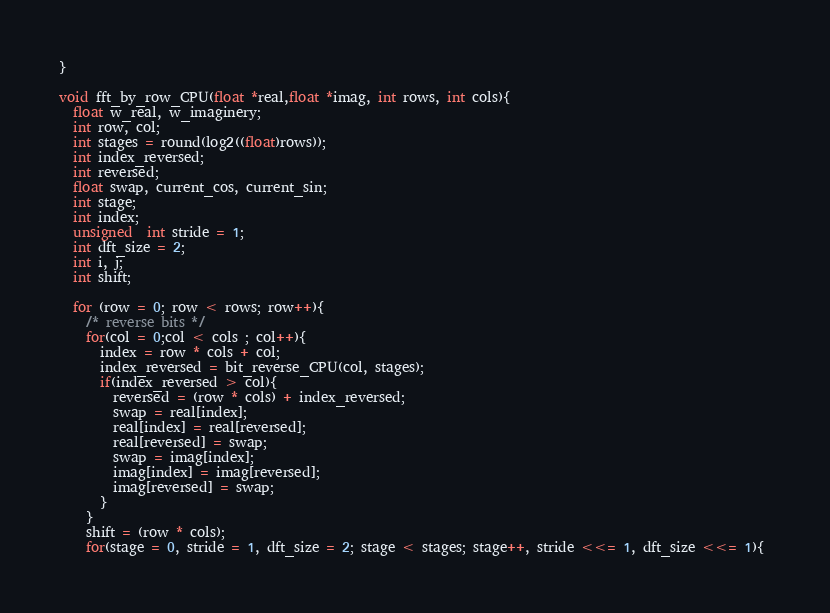<code> <loc_0><loc_0><loc_500><loc_500><_Cuda_>}

void fft_by_row_CPU(float *real,float *imag, int rows, int cols){
  float w_real, w_imaginery;
  int row, col;
  int stages = round(log2((float)rows));
  int index_reversed;
  int reversed;
  float swap, current_cos, current_sin;
  int stage;
  int index;
  unsigned  int stride = 1;
  int dft_size = 2;
  int i, j;
  int shift;

  for (row = 0; row < rows; row++){
    /* reverse bits */
    for(col = 0;col < cols ; col++){
      index = row * cols + col;
      index_reversed = bit_reverse_CPU(col, stages);
      if(index_reversed > col){
        reversed = (row * cols) + index_reversed;
        swap = real[index];
        real[index] = real[reversed];
        real[reversed] = swap;
        swap = imag[index];
        imag[index] = imag[reversed];
        imag[reversed] = swap;
      }
    }
    shift = (row * cols);
    for(stage = 0, stride = 1, dft_size = 2; stage < stages; stage++, stride <<= 1, dft_size <<= 1){ </code> 